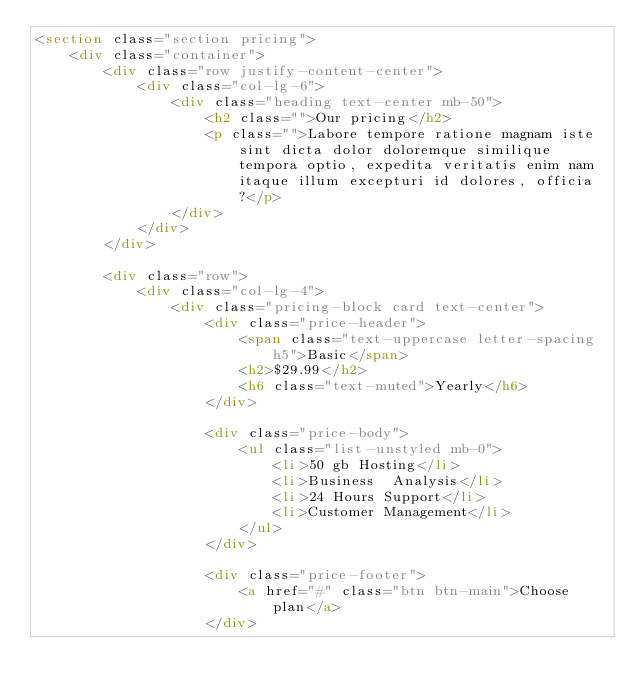Convert code to text. <code><loc_0><loc_0><loc_500><loc_500><_HTML_><section class="section pricing">
	<div class="container">
		<div class="row justify-content-center">
			<div class="col-lg-6">
				<div class="heading text-center mb-50">
					<h2 class="">Our pricing</h2>
					<p class="">Labore tempore ratione magnam iste sint dicta dolor doloremque similique tempora optio, expedita veritatis enim nam itaque illum excepturi id dolores, officia?</p>
				</div>
			</div>	
		</div>

		<div class="row">
			<div class="col-lg-4">
				<div class="pricing-block card text-center">
					<div class="price-header">
						<span class="text-uppercase letter-spacing h5">Basic</span>
						<h2>$29.99</h2>
						<h6 class="text-muted">Yearly</h6>
					</div>

					<div class="price-body">
						<ul class="list-unstyled mb-0">
							<li>50 gb Hosting</li>
							<li>Business  Analysis</li>
							<li>24 Hours Support</li>
							<li>Customer Management</li>
						</ul>
					</div>

					<div class="price-footer">
						<a href="#" class="btn btn-main">Choose plan</a>
					</div>
</code> 